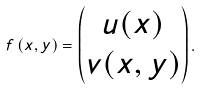Convert formula to latex. <formula><loc_0><loc_0><loc_500><loc_500>f \left ( x , y \right ) = \begin{pmatrix} u ( x ) \\ v ( x , y ) \end{pmatrix} .</formula> 